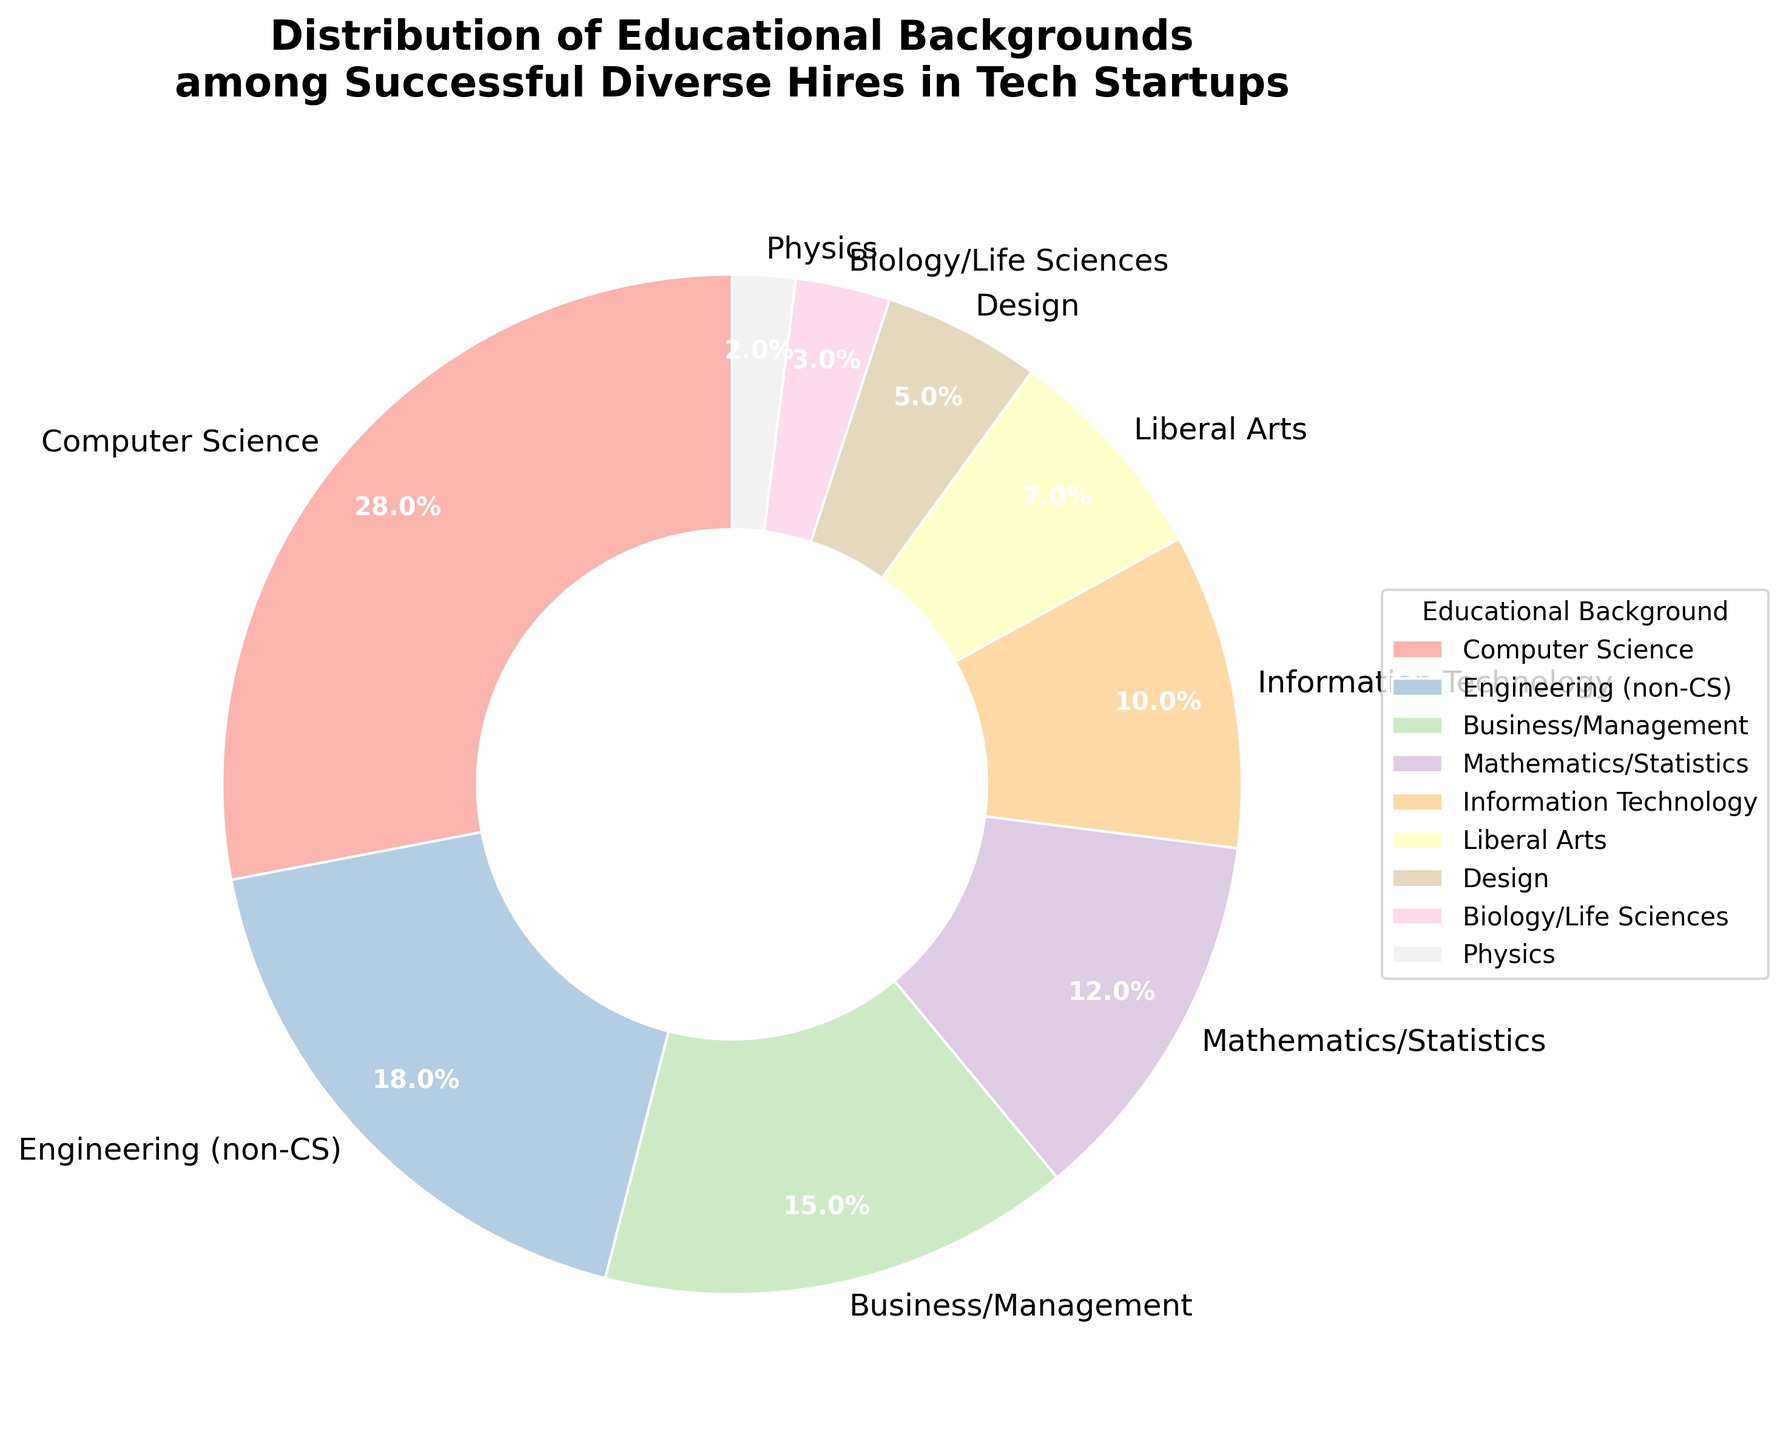What percentage of successful diverse hires have a Computer Science background? The figure shows that 28% of the successful diverse hires have a Computer Science background. You can directly read this value from the pie chart's segment labeled "Computer Science".
Answer: 28% How does the percentage of hires with a Business/Management background compare to those with an Engineering (non-CS) background? The figure shows that hires with a Business/Management background account for 15%, while those with an Engineering (non-CS) background account for 18%.
Answer: 15% is less than 18% Which educational background has the fewest successful hires, and what is that percentage? The figure indicates that Physics has the fewest successful hires among the different educational backgrounds, with a percentage of 2%.
Answer: Physics, 2% What is the combined percentage of successful hires from Mathematics/Statistics and Information Technology backgrounds? From the figure, Mathematics/Statistics and Information Technology account for 12% and 10% respectively. Adding these gives 12% + 10% = 22%.
Answer: 22% What is the total percentage of hires that have a background in Liberal Arts, Design, and Biology/Life Sciences combined? According to the figure, Liberal Arts has 7%, Design has 5%, and Biology/Life Sciences has 3%. The total percentage is 7% + 5% + 3% = 15%.
Answer: 15% Which two educational backgrounds, when combined, make up over 40% of the successful hires? The percentage of hires with a Computer Science background is 28%, and those with an Engineering (non-CS) background is 18%. Combined, their total is 28% + 18% = 46%, which is over 40%.
Answer: Computer Science and Engineering (non-CS) How does the percentage of those with a Mathematics/Statistics background compare to those with a Liberal Arts background? The figure shows that the percentage of hires with a Mathematics/Statistics background is 12%, while those with a Liberal Arts background is 7%.
Answer: 12% is higher than 7% What percentage of successful hires come from non-STEM (Science, Technology, Engineering, Mathematics) backgrounds? According to the pie chart, non-STEM backgrounds include Business/Management (15%), Liberal Arts (7%), and Design (5%). The total percentage is 15% + 7% + 5% = 27%.
Answer: 27% Which educational background category is depicted with the smallest wedge in the pie chart, and what might this indicate about diversity in educational backgrounds? The smallest wedge in the pie chart belongs to Physics, which has a 2% representation. This indicates that Physics is the least common educational background among the successful diverse hires in tech startups, suggesting these hires are less likely to come from a Physics background.
Answer: Physics, 2% 